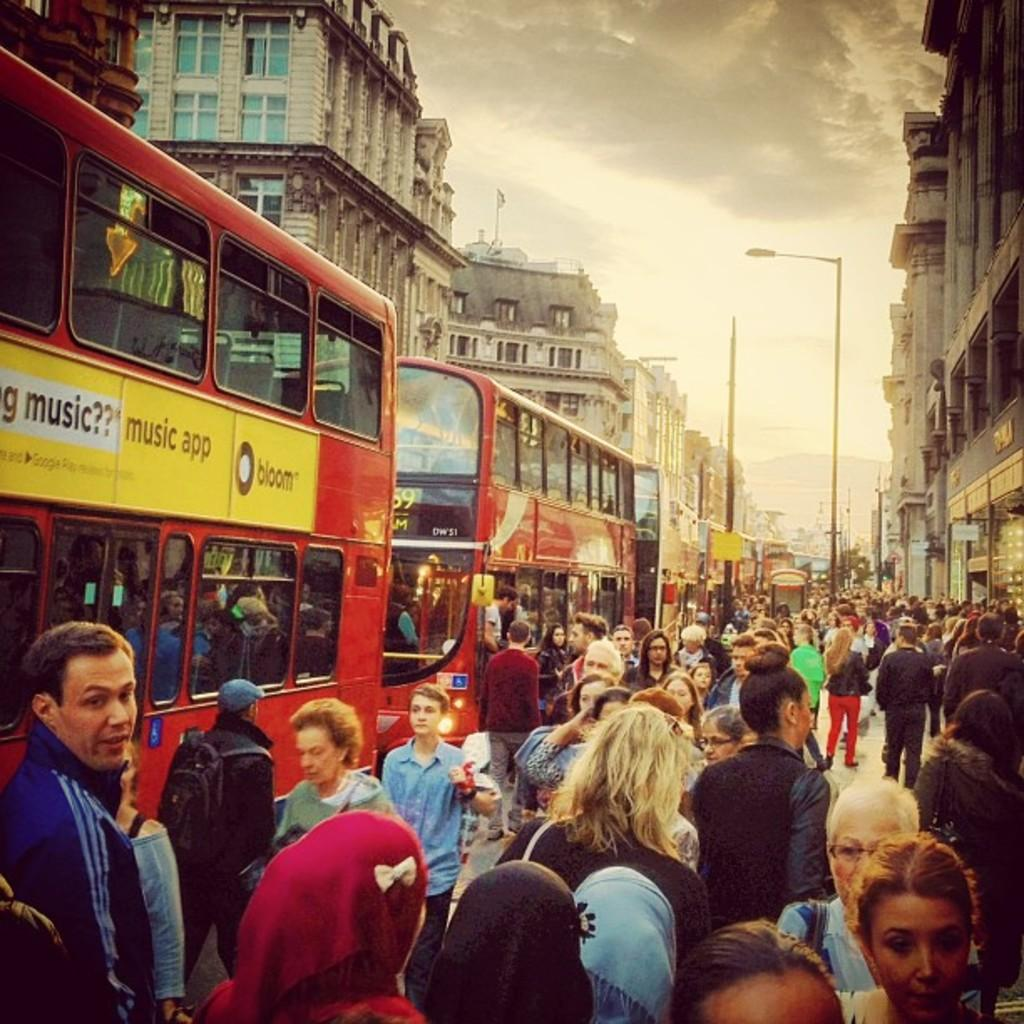Provide a one-sentence caption for the provided image. A lot of people are walking by a couple of buses, with a music app advertisement on one. 